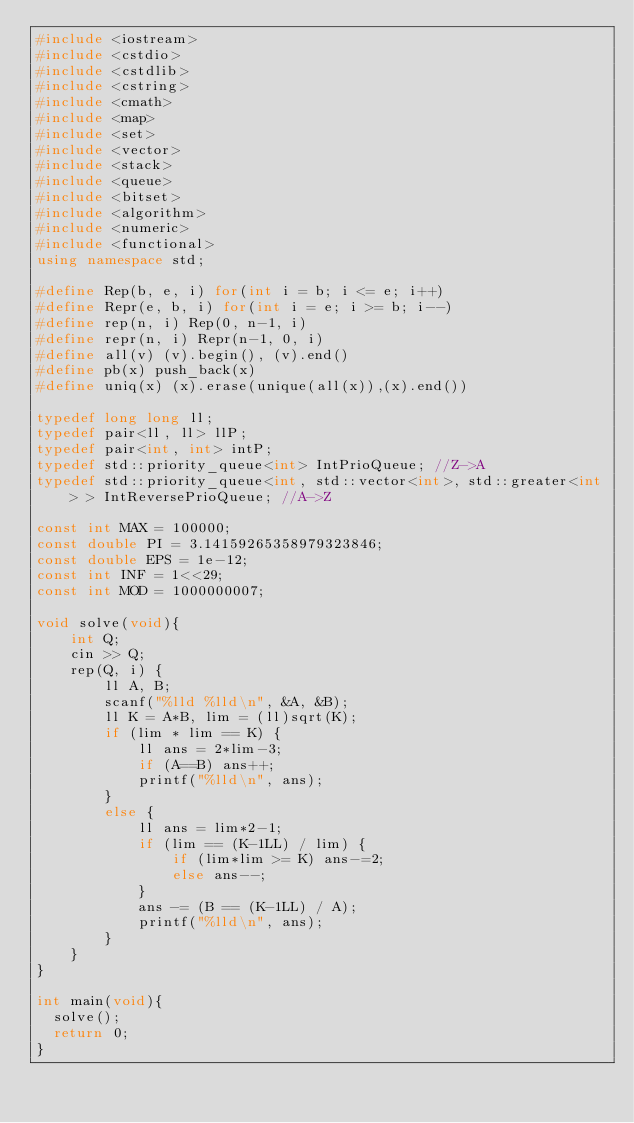<code> <loc_0><loc_0><loc_500><loc_500><_C++_>#include <iostream>
#include <cstdio>
#include <cstdlib>
#include <cstring>
#include <cmath>
#include <map>
#include <set>
#include <vector>
#include <stack>
#include <queue>
#include <bitset>
#include <algorithm>
#include <numeric>
#include <functional>
using namespace std;

#define Rep(b, e, i) for(int i = b; i <= e; i++)
#define Repr(e, b, i) for(int i = e; i >= b; i--)
#define rep(n, i) Rep(0, n-1, i)
#define repr(n, i) Repr(n-1, 0, i)
#define all(v) (v).begin(), (v).end()
#define pb(x) push_back(x)
#define uniq(x) (x).erase(unique(all(x)),(x).end())

typedef long long ll;
typedef pair<ll, ll> llP;
typedef pair<int, int> intP;
typedef std::priority_queue<int> IntPrioQueue; //Z->A
typedef std::priority_queue<int, std::vector<int>, std::greater<int> > IntReversePrioQueue; //A->Z

const int MAX = 100000;
const double PI = 3.14159265358979323846;
const double EPS = 1e-12;
const int INF = 1<<29;
const int MOD = 1000000007;

void solve(void){
    int Q;
    cin >> Q;
    rep(Q, i) {
        ll A, B;
        scanf("%lld %lld\n", &A, &B);
        ll K = A*B, lim = (ll)sqrt(K);
        if (lim * lim == K) {
            ll ans = 2*lim-3;
            if (A==B) ans++;
            printf("%lld\n", ans);
        }
        else {
            ll ans = lim*2-1;
            if (lim == (K-1LL) / lim) {
                if (lim*lim >= K) ans-=2;
                else ans--;
            }
            ans -= (B == (K-1LL) / A);
            printf("%lld\n", ans);
        }
    }
}

int main(void){
  solve();
  return 0;
}
</code> 